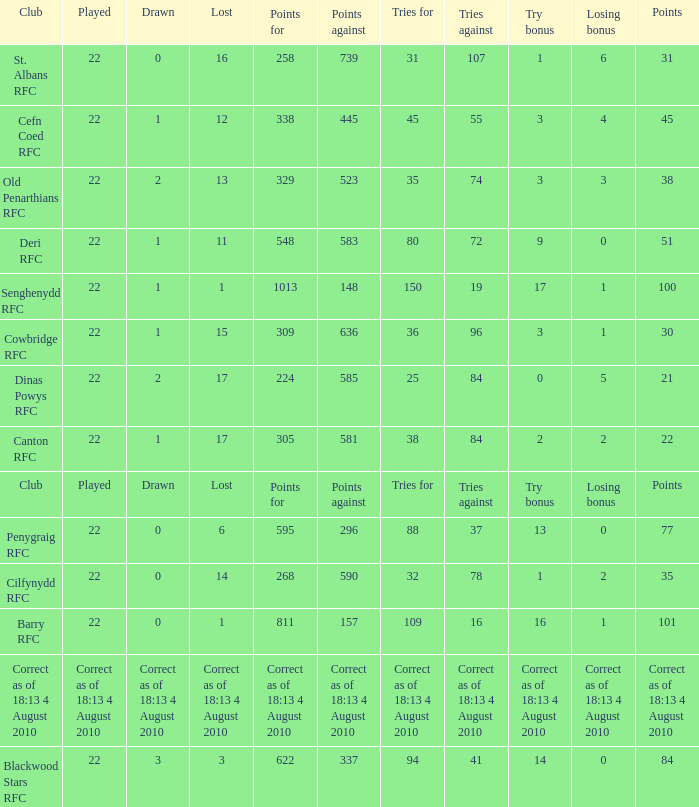What is the played number when tries against is 84, and drawn is 2? 22.0. 